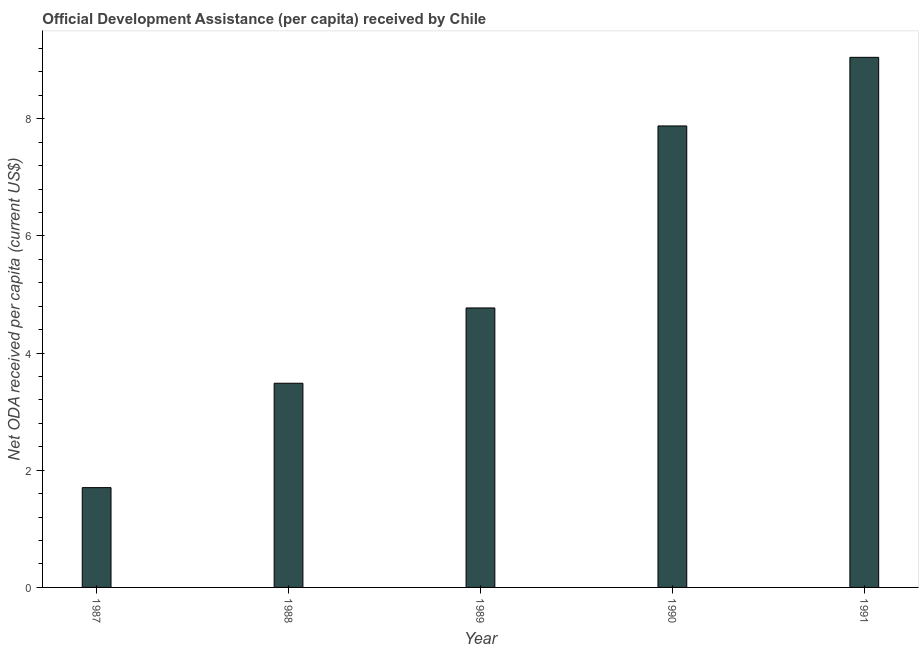Does the graph contain grids?
Your response must be concise. No. What is the title of the graph?
Offer a very short reply. Official Development Assistance (per capita) received by Chile. What is the label or title of the Y-axis?
Give a very brief answer. Net ODA received per capita (current US$). What is the net oda received per capita in 1987?
Keep it short and to the point. 1.7. Across all years, what is the maximum net oda received per capita?
Give a very brief answer. 9.05. Across all years, what is the minimum net oda received per capita?
Offer a very short reply. 1.7. What is the sum of the net oda received per capita?
Offer a very short reply. 26.89. What is the difference between the net oda received per capita in 1989 and 1990?
Your answer should be compact. -3.11. What is the average net oda received per capita per year?
Your answer should be compact. 5.38. What is the median net oda received per capita?
Make the answer very short. 4.77. What is the ratio of the net oda received per capita in 1988 to that in 1990?
Provide a succinct answer. 0.44. Is the net oda received per capita in 1989 less than that in 1990?
Your answer should be very brief. Yes. What is the difference between the highest and the second highest net oda received per capita?
Your answer should be compact. 1.17. Is the sum of the net oda received per capita in 1989 and 1990 greater than the maximum net oda received per capita across all years?
Provide a succinct answer. Yes. What is the difference between the highest and the lowest net oda received per capita?
Give a very brief answer. 7.35. In how many years, is the net oda received per capita greater than the average net oda received per capita taken over all years?
Your answer should be very brief. 2. Are all the bars in the graph horizontal?
Your answer should be compact. No. What is the Net ODA received per capita (current US$) of 1987?
Provide a succinct answer. 1.7. What is the Net ODA received per capita (current US$) in 1988?
Make the answer very short. 3.49. What is the Net ODA received per capita (current US$) in 1989?
Offer a very short reply. 4.77. What is the Net ODA received per capita (current US$) in 1990?
Your response must be concise. 7.88. What is the Net ODA received per capita (current US$) in 1991?
Your answer should be compact. 9.05. What is the difference between the Net ODA received per capita (current US$) in 1987 and 1988?
Offer a terse response. -1.78. What is the difference between the Net ODA received per capita (current US$) in 1987 and 1989?
Ensure brevity in your answer.  -3.07. What is the difference between the Net ODA received per capita (current US$) in 1987 and 1990?
Give a very brief answer. -6.18. What is the difference between the Net ODA received per capita (current US$) in 1987 and 1991?
Offer a terse response. -7.35. What is the difference between the Net ODA received per capita (current US$) in 1988 and 1989?
Make the answer very short. -1.29. What is the difference between the Net ODA received per capita (current US$) in 1988 and 1990?
Your answer should be compact. -4.39. What is the difference between the Net ODA received per capita (current US$) in 1988 and 1991?
Provide a succinct answer. -5.56. What is the difference between the Net ODA received per capita (current US$) in 1989 and 1990?
Your response must be concise. -3.11. What is the difference between the Net ODA received per capita (current US$) in 1989 and 1991?
Provide a succinct answer. -4.28. What is the difference between the Net ODA received per capita (current US$) in 1990 and 1991?
Offer a very short reply. -1.17. What is the ratio of the Net ODA received per capita (current US$) in 1987 to that in 1988?
Your answer should be compact. 0.49. What is the ratio of the Net ODA received per capita (current US$) in 1987 to that in 1989?
Your answer should be compact. 0.36. What is the ratio of the Net ODA received per capita (current US$) in 1987 to that in 1990?
Keep it short and to the point. 0.22. What is the ratio of the Net ODA received per capita (current US$) in 1987 to that in 1991?
Keep it short and to the point. 0.19. What is the ratio of the Net ODA received per capita (current US$) in 1988 to that in 1989?
Make the answer very short. 0.73. What is the ratio of the Net ODA received per capita (current US$) in 1988 to that in 1990?
Offer a terse response. 0.44. What is the ratio of the Net ODA received per capita (current US$) in 1988 to that in 1991?
Offer a terse response. 0.39. What is the ratio of the Net ODA received per capita (current US$) in 1989 to that in 1990?
Keep it short and to the point. 0.61. What is the ratio of the Net ODA received per capita (current US$) in 1989 to that in 1991?
Your response must be concise. 0.53. What is the ratio of the Net ODA received per capita (current US$) in 1990 to that in 1991?
Keep it short and to the point. 0.87. 